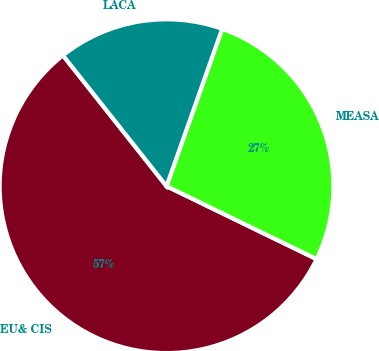Convert chart. <chart><loc_0><loc_0><loc_500><loc_500><pie_chart><fcel>EU& CIS<fcel>MEASA<fcel>LACA<nl><fcel>57.14%<fcel>26.79%<fcel>16.07%<nl></chart> 